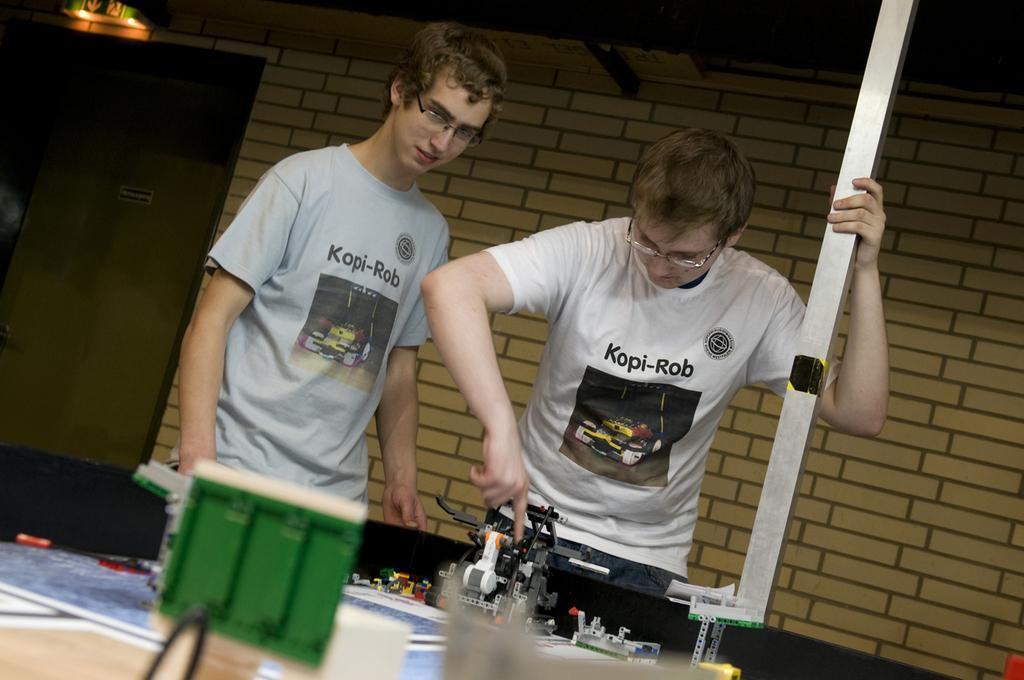In one or two sentences, can you explain what this image depicts? In this image we can see two persons standing. In that a man is holding a pole. On the backside we can see the wall. 